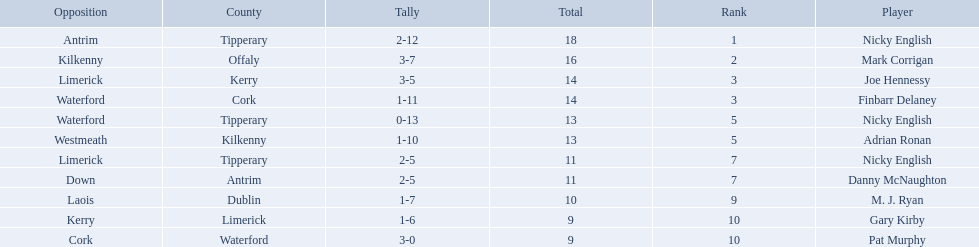Which of the following players were ranked in the bottom 5? Nicky English, Danny McNaughton, M. J. Ryan, Gary Kirby, Pat Murphy. Of these, whose tallies were not 2-5? M. J. Ryan, Gary Kirby, Pat Murphy. From the above three, which one scored more than 9 total points? M. J. Ryan. 